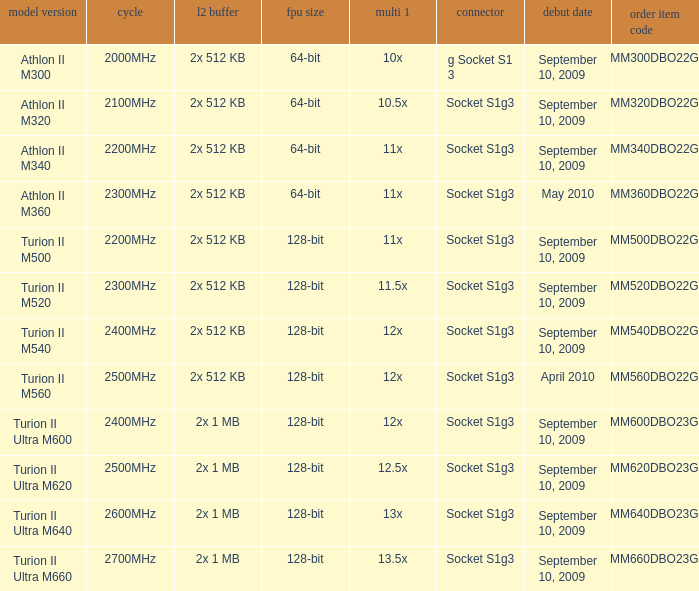What is the frequency of the tmm500dbo22gq order part number? 2200MHz. 